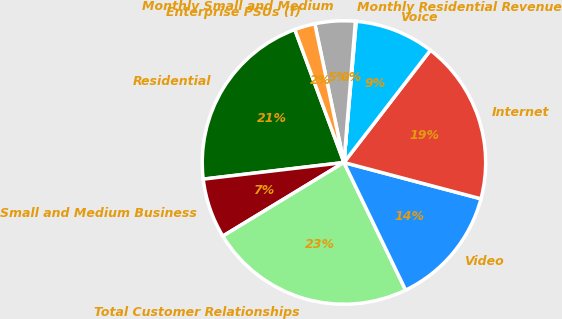Convert chart. <chart><loc_0><loc_0><loc_500><loc_500><pie_chart><fcel>Residential<fcel>Small and Medium Business<fcel>Total Customer Relationships<fcel>Video<fcel>Internet<fcel>Voice<fcel>Monthly Residential Revenue<fcel>Monthly Small and Medium<fcel>Enterprise PSUs (f)<nl><fcel>21.24%<fcel>6.82%<fcel>23.48%<fcel>13.71%<fcel>18.68%<fcel>9.07%<fcel>0.09%<fcel>4.58%<fcel>2.34%<nl></chart> 